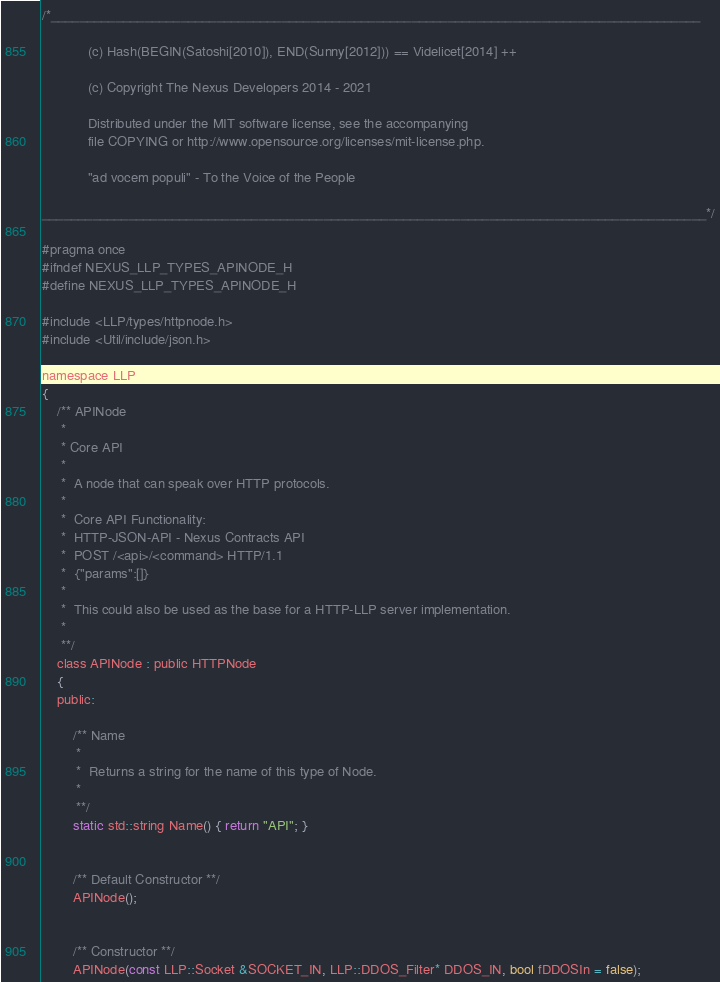<code> <loc_0><loc_0><loc_500><loc_500><_C_>/*__________________________________________________________________________________________

            (c) Hash(BEGIN(Satoshi[2010]), END(Sunny[2012])) == Videlicet[2014] ++

            (c) Copyright The Nexus Developers 2014 - 2021

            Distributed under the MIT software license, see the accompanying
            file COPYING or http://www.opensource.org/licenses/mit-license.php.

            "ad vocem populi" - To the Voice of the People

____________________________________________________________________________________________*/

#pragma once
#ifndef NEXUS_LLP_TYPES_APINODE_H
#define NEXUS_LLP_TYPES_APINODE_H

#include <LLP/types/httpnode.h>
#include <Util/include/json.h>

namespace LLP
{
    /** APINode
     *
     * Core API
     *
     *  A node that can speak over HTTP protocols.
     *
     *  Core API Functionality:
     *  HTTP-JSON-API - Nexus Contracts API
     *  POST /<api>/<command> HTTP/1.1
     *  {"params":[]}
     *
     *  This could also be used as the base for a HTTP-LLP server implementation.
     *
     **/
    class APINode : public HTTPNode
    {
    public:

        /** Name
         *
         *  Returns a string for the name of this type of Node.
         *
         **/
        static std::string Name() { return "API"; }


        /** Default Constructor **/
        APINode();


        /** Constructor **/
        APINode(const LLP::Socket &SOCKET_IN, LLP::DDOS_Filter* DDOS_IN, bool fDDOSIn = false);

</code> 